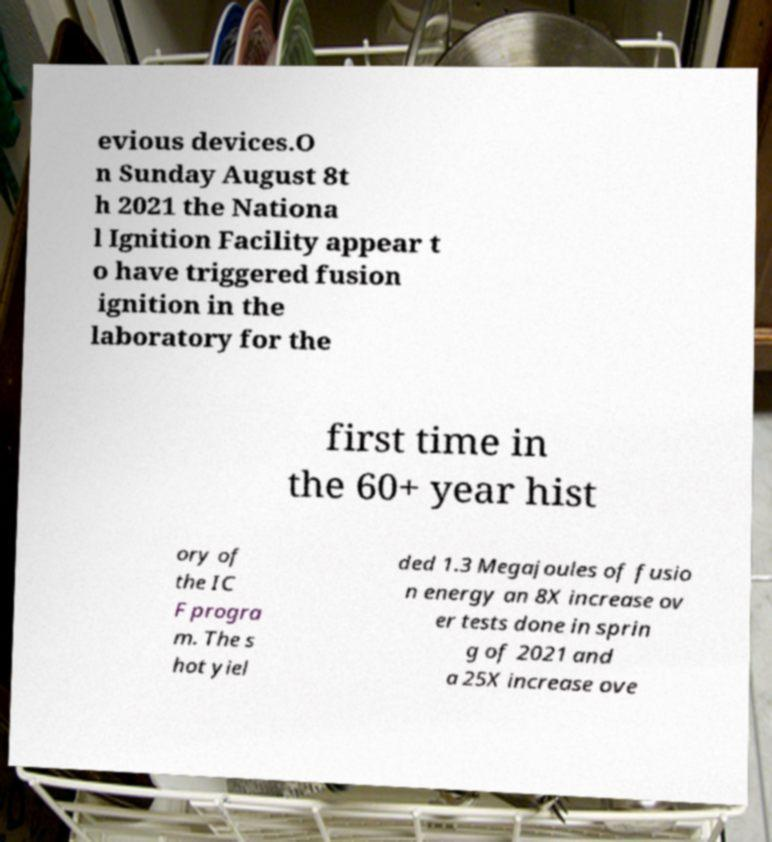Can you read and provide the text displayed in the image?This photo seems to have some interesting text. Can you extract and type it out for me? evious devices.O n Sunday August 8t h 2021 the Nationa l Ignition Facility appear t o have triggered fusion ignition in the laboratory for the first time in the 60+ year hist ory of the IC F progra m. The s hot yiel ded 1.3 Megajoules of fusio n energy an 8X increase ov er tests done in sprin g of 2021 and a 25X increase ove 